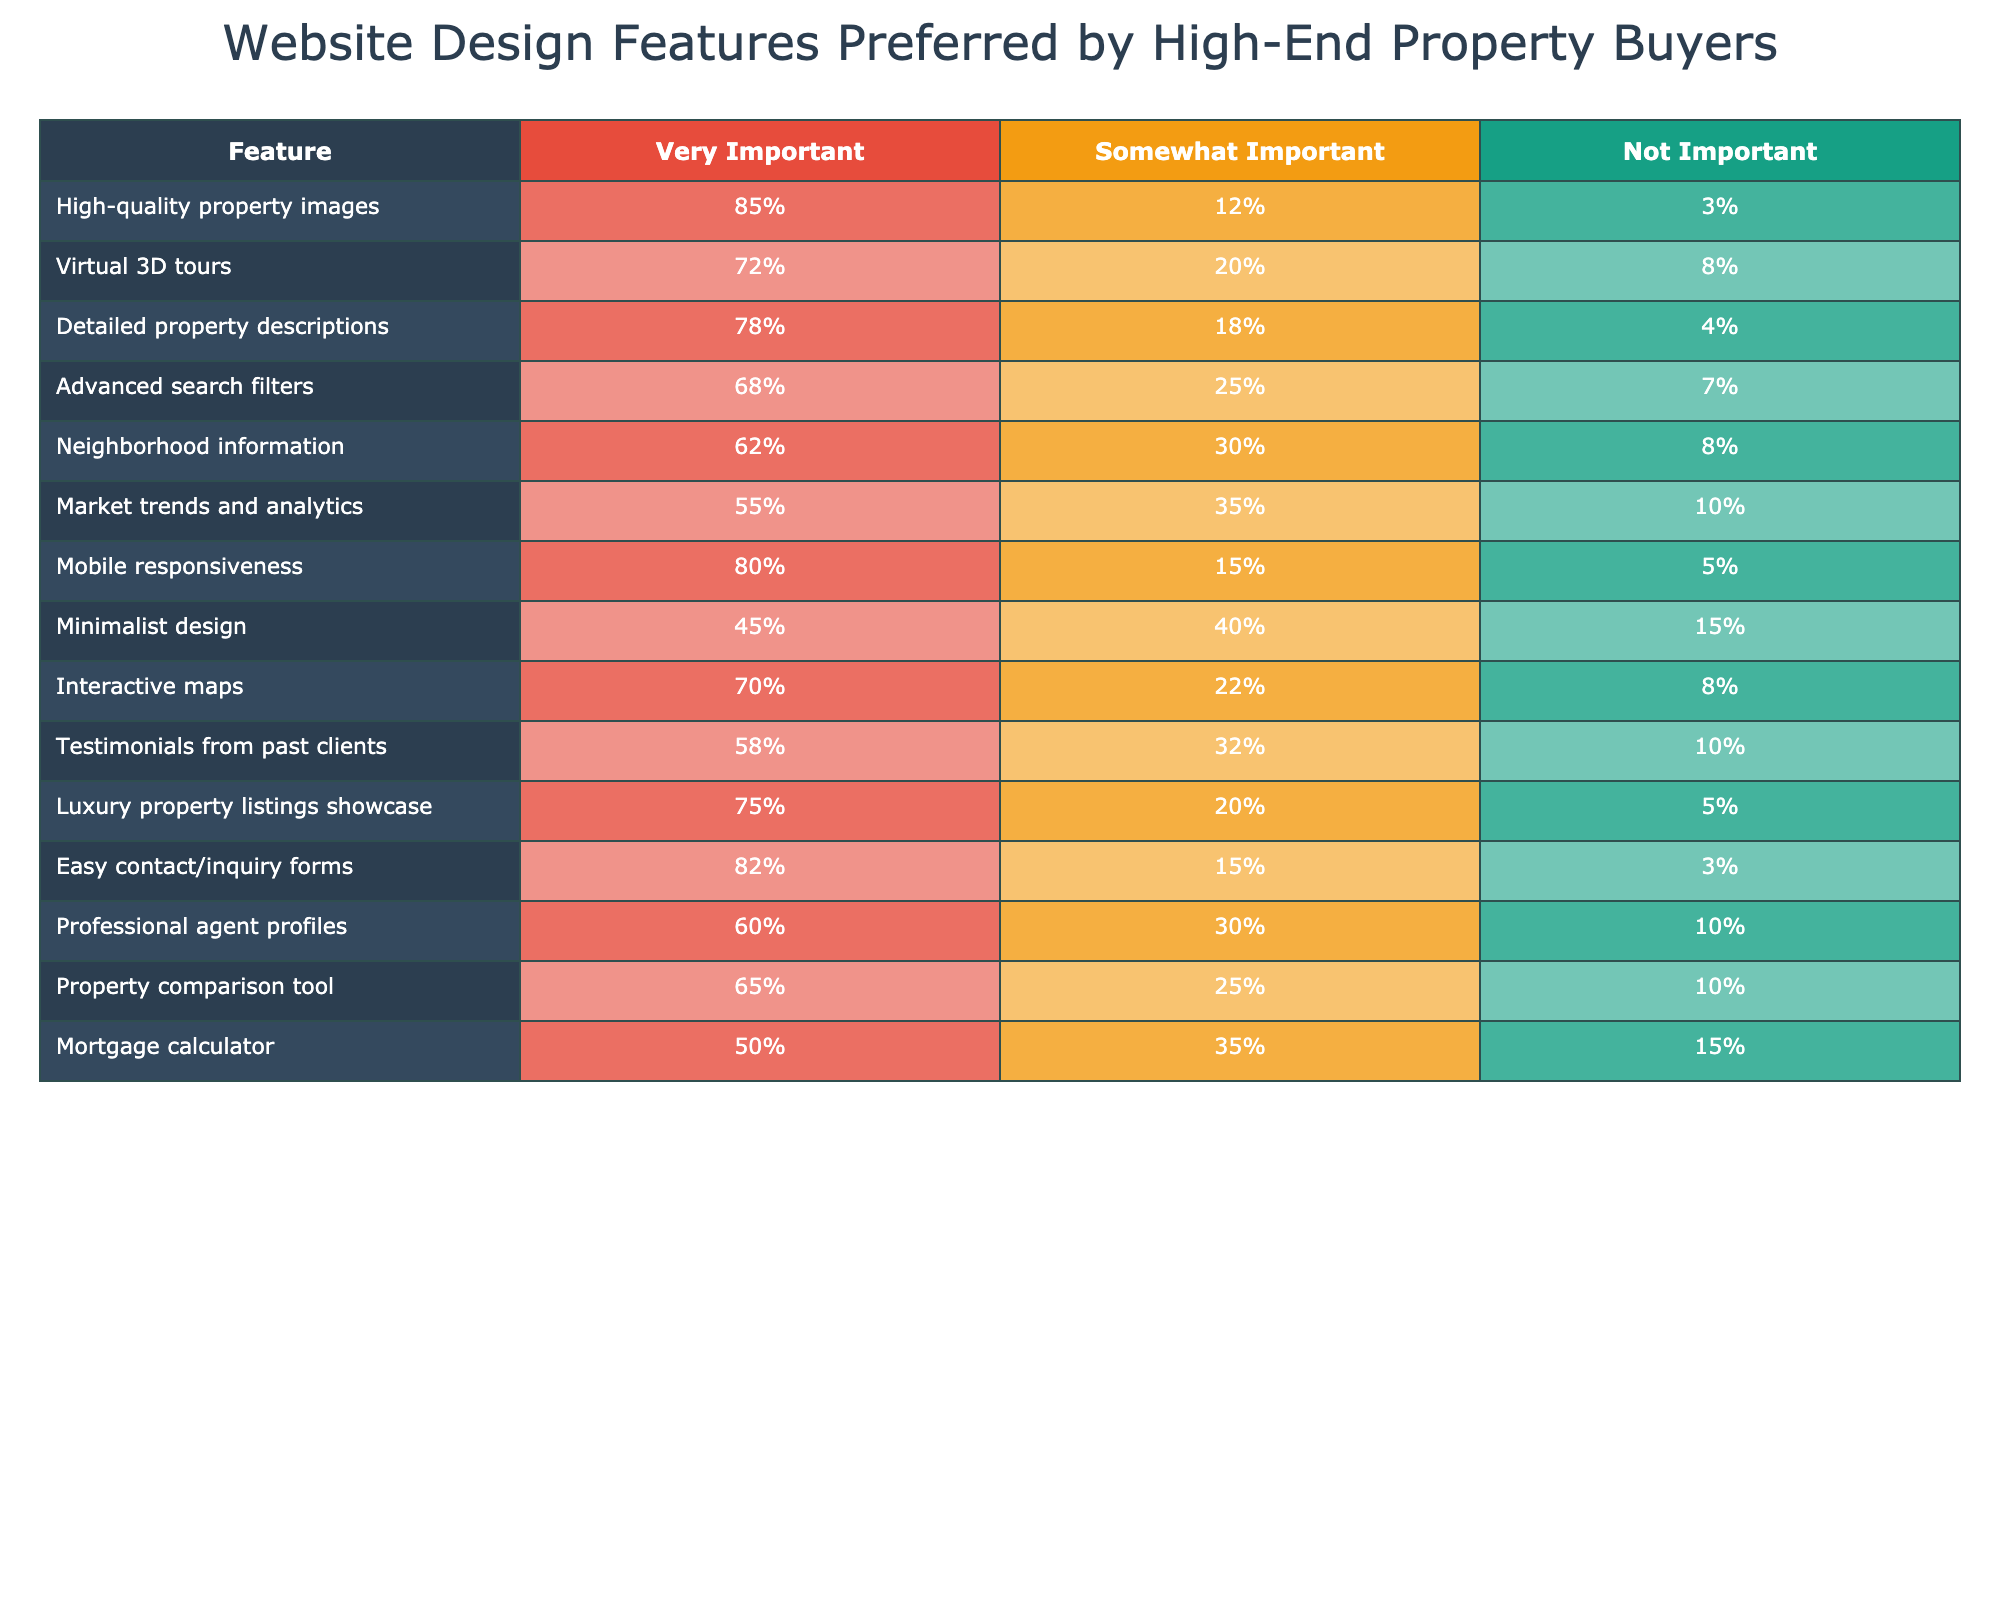What percentage of respondents found high-quality property images very important? According to the table, 85% of respondents indicated that high-quality property images are very important.
Answer: 85% Which feature has the lowest percentage of respondents rating it as very important? From the table, the feature with the lowest percentage rated as very important is minimalist design, which is at 45%.
Answer: 45% What is the difference between the percentages of respondents who rated mobile responsiveness as very important versus those who rated it as not important? Mobile responsiveness was rated as very important by 80% of respondents and as not important by 5%. The difference is 80% - 5% = 75%.
Answer: 75% How many features have more than 70% of respondents rating them as very important? The table shows that high-quality property images (85%), virtual 3D tours (72%), detailed property descriptions (78%), mobile responsiveness (80%), interactive maps (70%), and luxury property listings showcase (75%) all have over 70%. This sums to six features.
Answer: 6 Is there a feature that 100% of respondents considered important either somewhat important or very important? By checking the combined percentages of somewhat important (shown in the table) and very important, no feature reaches 100%. Even the most important features have percentages lower than 100% when added together.
Answer: No What is the average percentage of respondents rating features as very important? To find the average, we total the very important percentages: 85 + 72 + 78 + 68 + 62 + 55 + 80 + 45 + 70 + 58 + 75 + 82 + 60 + 65 + 50 = 1035%. There are 15 features, so the average is 1035/15 = 69%.
Answer: 69% Which feature had the highest percentage of respondents rating it as somewhat important? The table indicates that the feature with the highest percentage of somewhat important ratings is advanced search filters at 25%.
Answer: 25% What is the combined percentage of respondents who rated testimonials from past clients as somewhat important or not important? Testimonials from past clients received a somewhat important rating of 32% and a not important rating of 10%. So, the combined percentage is 32% + 10% = 42%.
Answer: 42% Which feature has the same percentage of respondents rating it as not important as the mortgage calculator feature? The mortgage calculator shows 15% of respondents rating it as not important. A comparison of the table indicates that it is indeed the same for minimalist design, which also has a not important rating of 15%.
Answer: Minimalist design 